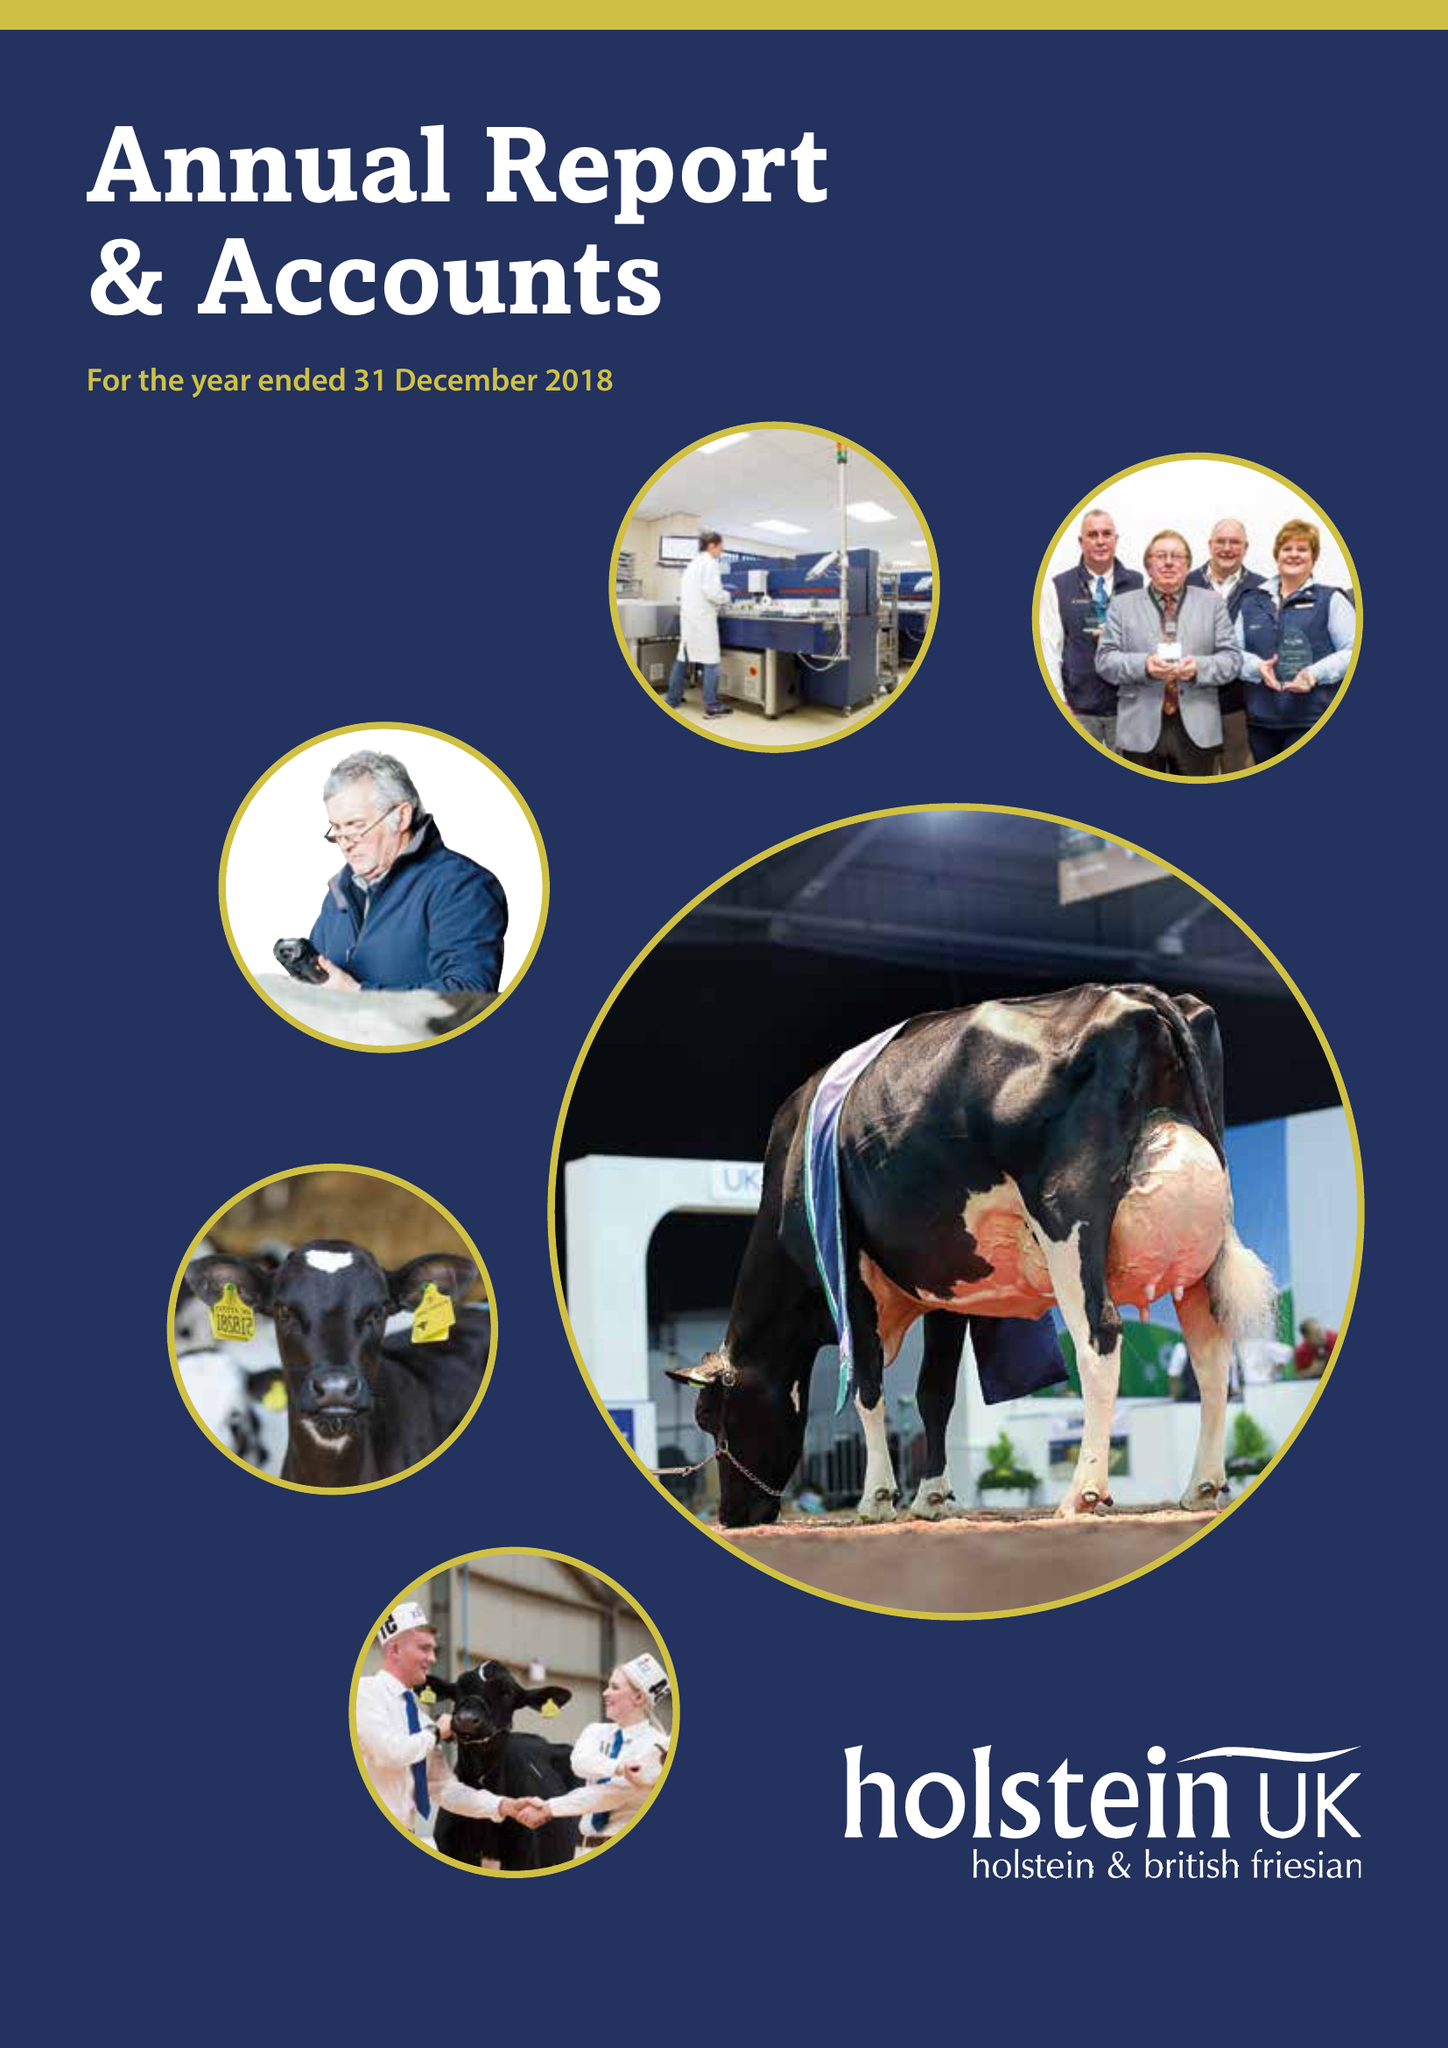What is the value for the address__post_town?
Answer the question using a single word or phrase. TELFORD 